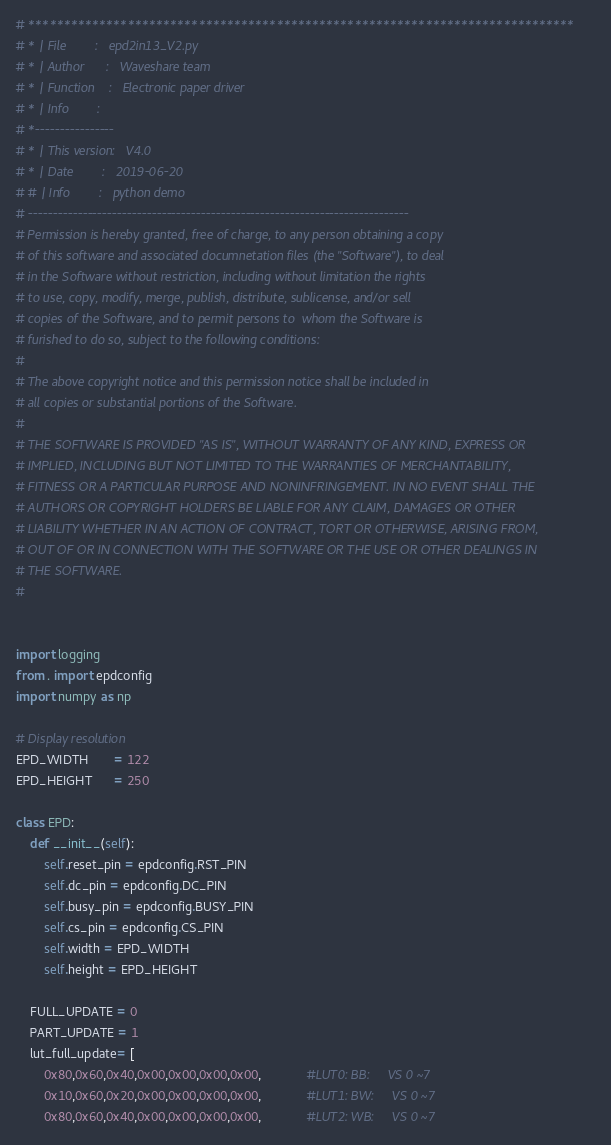<code> <loc_0><loc_0><loc_500><loc_500><_Python_># *****************************************************************************
# * | File        :	  epd2in13_V2.py
# * | Author      :   Waveshare team
# * | Function    :   Electronic paper driver
# * | Info        :
# *----------------
# * | This version:   V4.0
# * | Date        :   2019-06-20
# # | Info        :   python demo
# -----------------------------------------------------------------------------
# Permission is hereby granted, free of charge, to any person obtaining a copy
# of this software and associated documnetation files (the "Software"), to deal
# in the Software without restriction, including without limitation the rights
# to use, copy, modify, merge, publish, distribute, sublicense, and/or sell
# copies of the Software, and to permit persons to  whom the Software is
# furished to do so, subject to the following conditions:
#
# The above copyright notice and this permission notice shall be included in
# all copies or substantial portions of the Software.
#
# THE SOFTWARE IS PROVIDED "AS IS", WITHOUT WARRANTY OF ANY KIND, EXPRESS OR
# IMPLIED, INCLUDING BUT NOT LIMITED TO THE WARRANTIES OF MERCHANTABILITY,
# FITNESS OR A PARTICULAR PURPOSE AND NONINFRINGEMENT. IN NO EVENT SHALL THE
# AUTHORS OR COPYRIGHT HOLDERS BE LIABLE FOR ANY CLAIM, DAMAGES OR OTHER
# LIABILITY WHETHER IN AN ACTION OF CONTRACT, TORT OR OTHERWISE, ARISING FROM,
# OUT OF OR IN CONNECTION WITH THE SOFTWARE OR THE USE OR OTHER DEALINGS IN
# THE SOFTWARE.
#


import logging
from . import epdconfig
import numpy as np

# Display resolution
EPD_WIDTH       = 122
EPD_HEIGHT      = 250

class EPD:
    def __init__(self):
        self.reset_pin = epdconfig.RST_PIN
        self.dc_pin = epdconfig.DC_PIN
        self.busy_pin = epdconfig.BUSY_PIN
        self.cs_pin = epdconfig.CS_PIN
        self.width = EPD_WIDTH
        self.height = EPD_HEIGHT
        
    FULL_UPDATE = 0
    PART_UPDATE = 1
    lut_full_update= [
        0x80,0x60,0x40,0x00,0x00,0x00,0x00,             #LUT0: BB:     VS 0 ~7
        0x10,0x60,0x20,0x00,0x00,0x00,0x00,             #LUT1: BW:     VS 0 ~7
        0x80,0x60,0x40,0x00,0x00,0x00,0x00,             #LUT2: WB:     VS 0 ~7</code> 